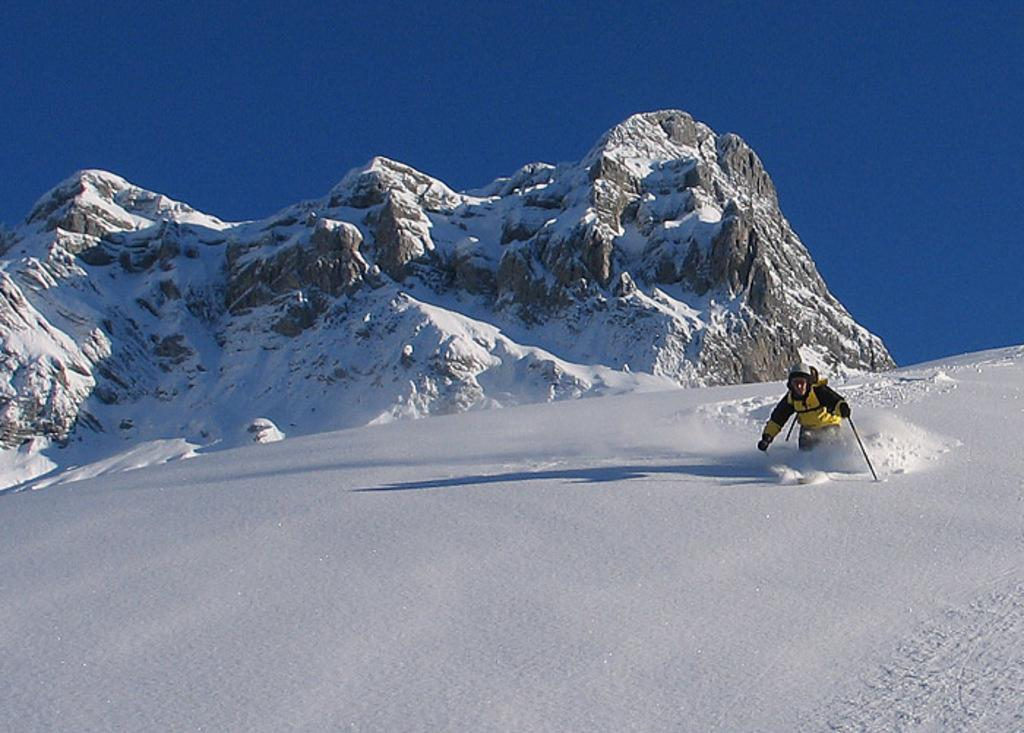What is the main subject of the image? There is there a person in the image? What is the person wearing? The person is wearing clothes. What is the person holding in his hand? The person is holding a stick with his hand. What can be seen in the middle of the image? There is a mountain in the middle of the image. What is visible at the top of the image? The sky is visible at the top of the image. Can you tell me how many times the person jumps in the image? There is no indication of the person jumping in the image. What type of pen is the person using to write in the image? There is no pen present in the image; the person is holding a stick. 